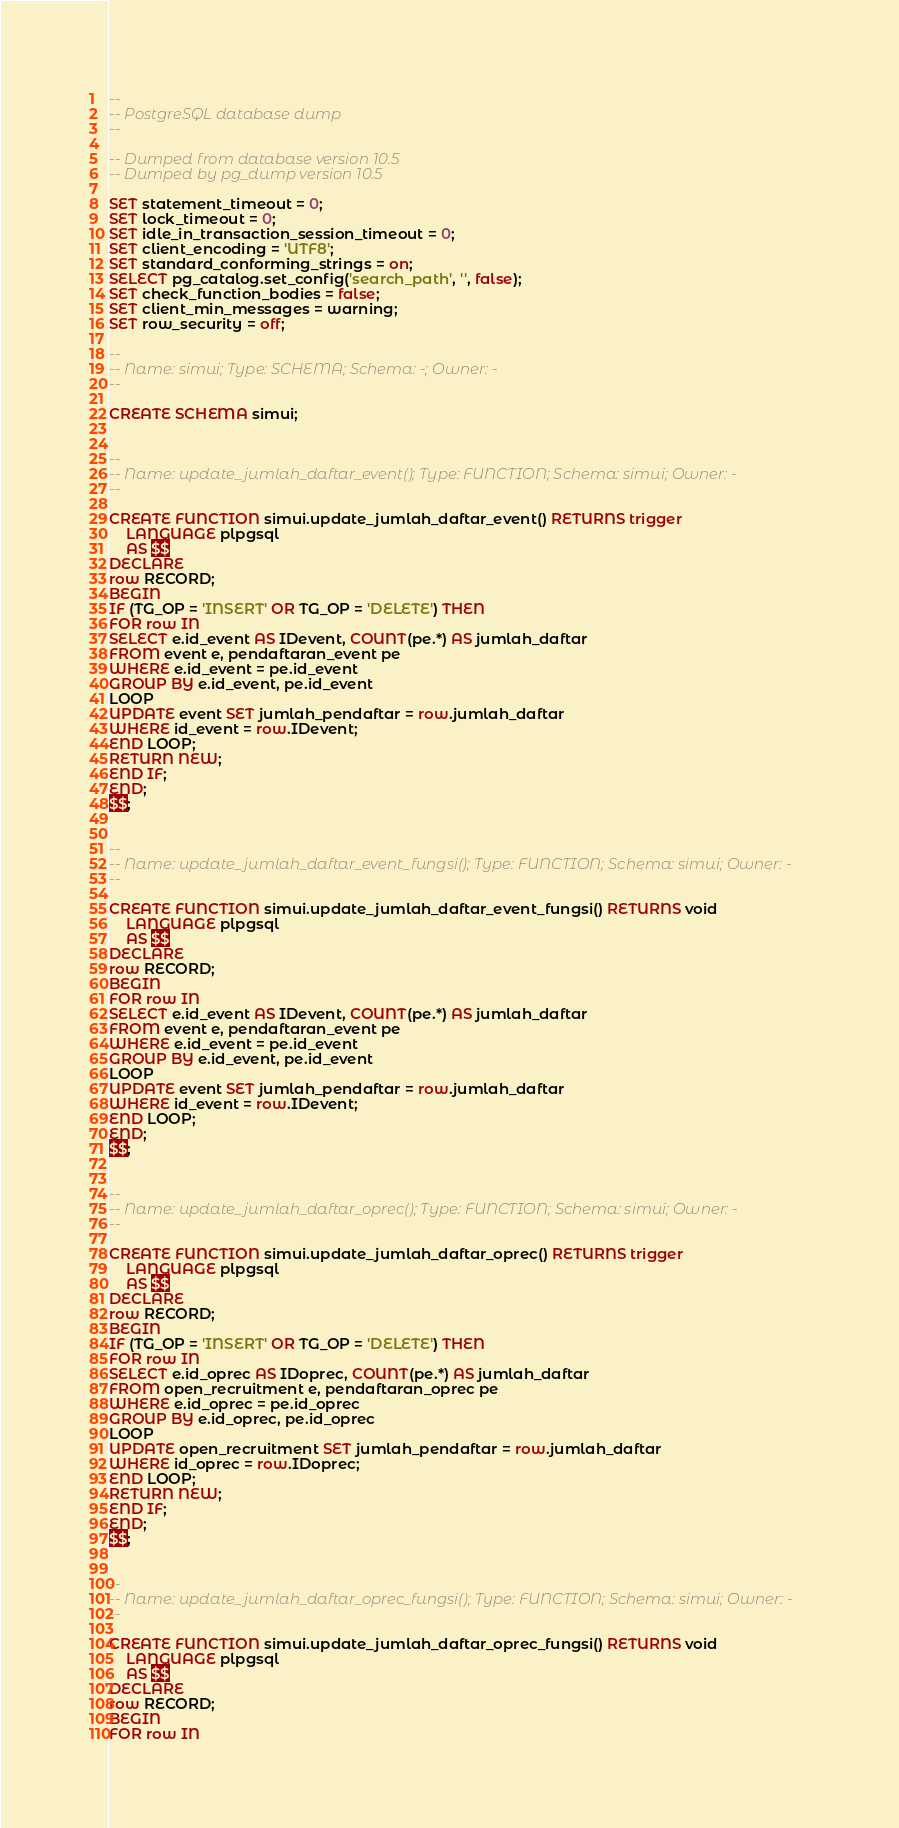<code> <loc_0><loc_0><loc_500><loc_500><_SQL_>--
-- PostgreSQL database dump
--

-- Dumped from database version 10.5
-- Dumped by pg_dump version 10.5

SET statement_timeout = 0;
SET lock_timeout = 0;
SET idle_in_transaction_session_timeout = 0;
SET client_encoding = 'UTF8';
SET standard_conforming_strings = on;
SELECT pg_catalog.set_config('search_path', '', false);
SET check_function_bodies = false;
SET client_min_messages = warning;
SET row_security = off;

--
-- Name: simui; Type: SCHEMA; Schema: -; Owner: -
--

CREATE SCHEMA simui;


--
-- Name: update_jumlah_daftar_event(); Type: FUNCTION; Schema: simui; Owner: -
--

CREATE FUNCTION simui.update_jumlah_daftar_event() RETURNS trigger
    LANGUAGE plpgsql
    AS $$
DECLARE
row RECORD;
BEGIN
IF (TG_OP = 'INSERT' OR TG_OP = 'DELETE') THEN
FOR row IN
SELECT e.id_event AS IDevent, COUNT(pe.*) AS jumlah_daftar
FROM event e, pendaftaran_event pe
WHERE e.id_event = pe.id_event
GROUP BY e.id_event, pe.id_event
LOOP
UPDATE event SET jumlah_pendaftar = row.jumlah_daftar
WHERE id_event = row.IDevent;
END LOOP;
RETURN NEW;
END IF;
END;
$$;


--
-- Name: update_jumlah_daftar_event_fungsi(); Type: FUNCTION; Schema: simui; Owner: -
--

CREATE FUNCTION simui.update_jumlah_daftar_event_fungsi() RETURNS void
    LANGUAGE plpgsql
    AS $$
DECLARE
row RECORD;
BEGIN
FOR row IN
SELECT e.id_event AS IDevent, COUNT(pe.*) AS jumlah_daftar
FROM event e, pendaftaran_event pe
WHERE e.id_event = pe.id_event
GROUP BY e.id_event, pe.id_event
LOOP
UPDATE event SET jumlah_pendaftar = row.jumlah_daftar
WHERE id_event = row.IDevent;
END LOOP;
END;
$$;


--
-- Name: update_jumlah_daftar_oprec(); Type: FUNCTION; Schema: simui; Owner: -
--

CREATE FUNCTION simui.update_jumlah_daftar_oprec() RETURNS trigger
    LANGUAGE plpgsql
    AS $$
DECLARE
row RECORD;
BEGIN
IF (TG_OP = 'INSERT' OR TG_OP = 'DELETE') THEN
FOR row IN
SELECT e.id_oprec AS IDoprec, COUNT(pe.*) AS jumlah_daftar
FROM open_recruitment e, pendaftaran_oprec pe
WHERE e.id_oprec = pe.id_oprec
GROUP BY e.id_oprec, pe.id_oprec
LOOP
UPDATE open_recruitment SET jumlah_pendaftar = row.jumlah_daftar
WHERE id_oprec = row.IDoprec;
END LOOP;
RETURN NEW;
END IF;
END;
$$;


--
-- Name: update_jumlah_daftar_oprec_fungsi(); Type: FUNCTION; Schema: simui; Owner: -
--

CREATE FUNCTION simui.update_jumlah_daftar_oprec_fungsi() RETURNS void
    LANGUAGE plpgsql
    AS $$
DECLARE
row RECORD;
BEGIN
FOR row IN</code> 